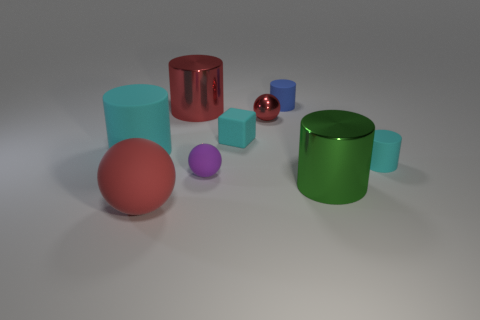Subtract all blue cylinders. How many cylinders are left? 4 Subtract all big cyan rubber cylinders. How many cylinders are left? 4 Subtract all yellow cylinders. Subtract all green spheres. How many cylinders are left? 5 Add 1 large shiny cylinders. How many objects exist? 10 Subtract all cylinders. How many objects are left? 4 Add 6 small blue metallic spheres. How many small blue metallic spheres exist? 6 Subtract 1 red cylinders. How many objects are left? 8 Subtract all blue matte cylinders. Subtract all big red metallic cylinders. How many objects are left? 7 Add 9 purple objects. How many purple objects are left? 10 